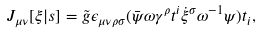<formula> <loc_0><loc_0><loc_500><loc_500>J _ { \mu \nu } [ \xi | s ] = \tilde { g } \epsilon _ { \mu \nu \rho \sigma } ( \bar { \psi } \omega \gamma ^ { \rho } t ^ { i } \dot { \xi } ^ { \sigma } \omega ^ { - 1 } \psi ) t _ { i } ,</formula> 